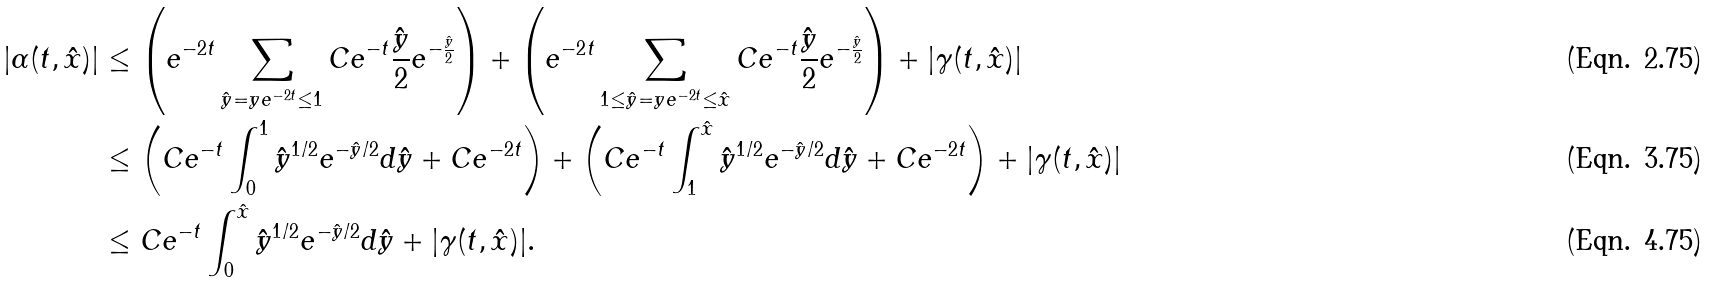Convert formula to latex. <formula><loc_0><loc_0><loc_500><loc_500>| \alpha ( t , \hat { x } ) | & \leq \left ( e ^ { - 2 t } \sum _ { \hat { y } = y e ^ { - 2 t } \leq 1 } C e ^ { - t } \frac { \hat { y } } { 2 } e ^ { - \frac { \hat { y } } { 2 } } \right ) + \left ( e ^ { - 2 t } \sum _ { 1 \leq \hat { y } = y e ^ { - 2 t } \leq \hat { x } } C e ^ { - t } \frac { \hat { y } } { 2 } e ^ { - \frac { \hat { y } } { 2 } } \right ) + | \gamma ( t , \hat { x } ) | \\ & \leq \left ( C e ^ { - t } \int _ { 0 } ^ { 1 } \hat { y } ^ { 1 / 2 } e ^ { - \hat { y } / 2 } d \hat { y } + C e ^ { - 2 t } \right ) + \left ( C e ^ { - t } \int _ { 1 } ^ { \hat { x } } \hat { y } ^ { 1 / 2 } e ^ { - \hat { y } / 2 } d \hat { y } + C e ^ { - 2 t } \right ) + | \gamma ( t , \hat { x } ) | \\ & \leq C e ^ { - t } \int _ { 0 } ^ { \hat { x } } \hat { y } ^ { 1 / 2 } e ^ { - \hat { y } / 2 } d \hat { y } + | \gamma ( t , \hat { x } ) | .</formula> 